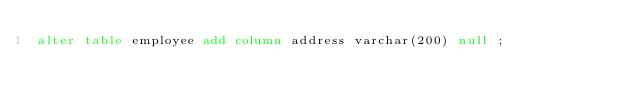<code> <loc_0><loc_0><loc_500><loc_500><_SQL_>alter table employee add column address varchar(200) null ;</code> 